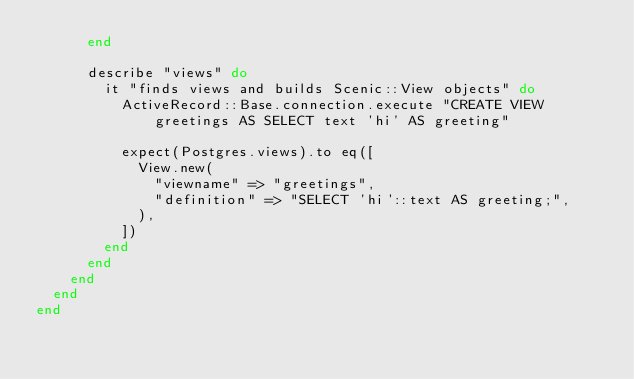Convert code to text. <code><loc_0><loc_0><loc_500><loc_500><_Ruby_>      end

      describe "views" do
        it "finds views and builds Scenic::View objects" do
          ActiveRecord::Base.connection.execute "CREATE VIEW greetings AS SELECT text 'hi' AS greeting"

          expect(Postgres.views).to eq([
            View.new(
              "viewname" => "greetings",
              "definition" => "SELECT 'hi'::text AS greeting;",
            ),
          ])
        end
      end
    end
  end
end
</code> 